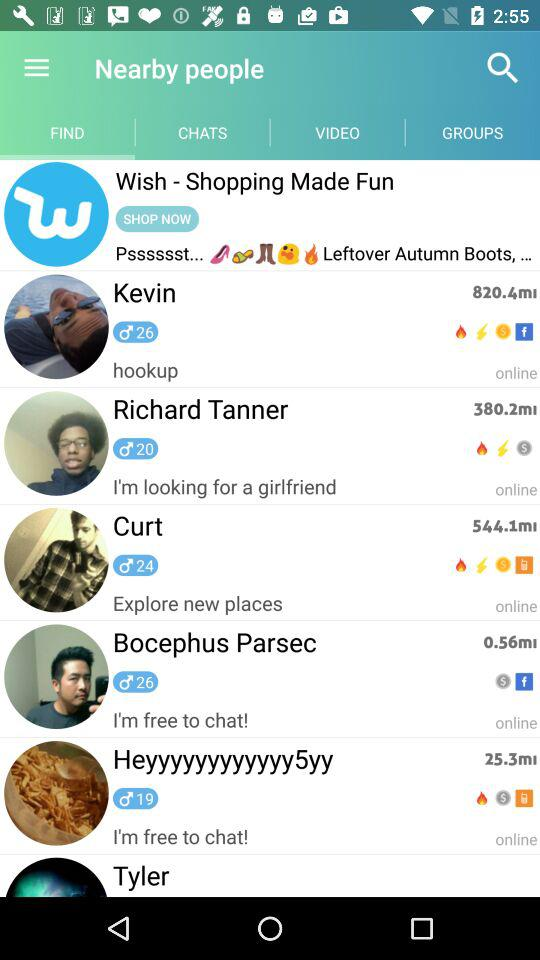How many people are online?
Answer the question using a single word or phrase. 6 